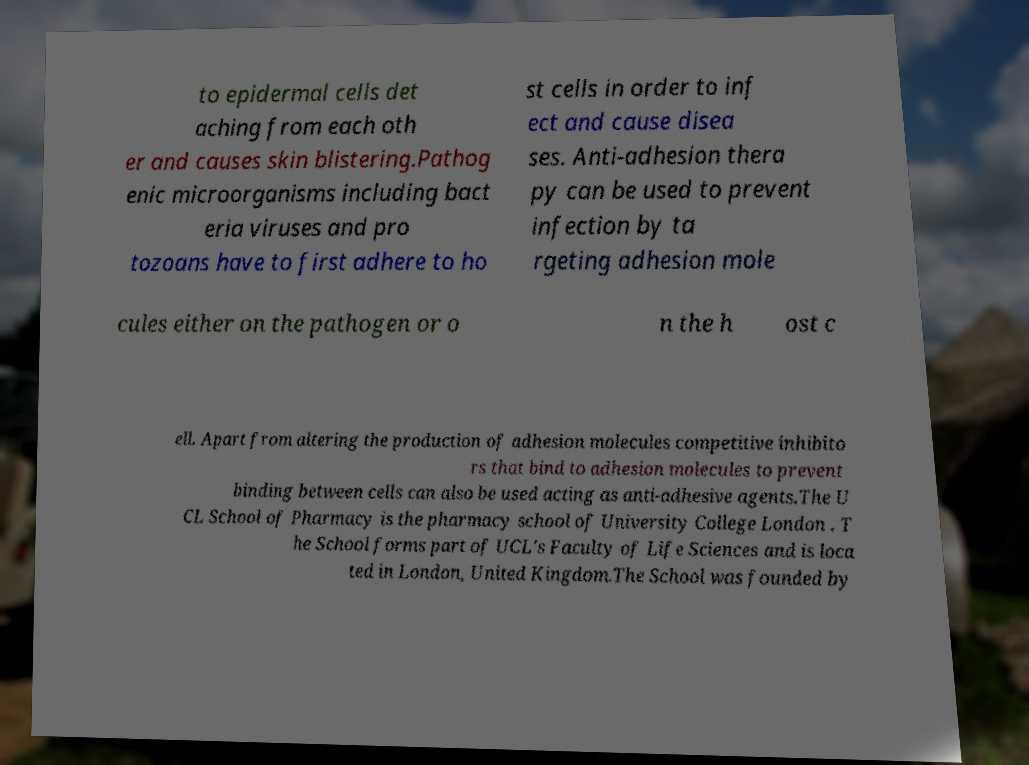Could you assist in decoding the text presented in this image and type it out clearly? to epidermal cells det aching from each oth er and causes skin blistering.Pathog enic microorganisms including bact eria viruses and pro tozoans have to first adhere to ho st cells in order to inf ect and cause disea ses. Anti-adhesion thera py can be used to prevent infection by ta rgeting adhesion mole cules either on the pathogen or o n the h ost c ell. Apart from altering the production of adhesion molecules competitive inhibito rs that bind to adhesion molecules to prevent binding between cells can also be used acting as anti-adhesive agents.The U CL School of Pharmacy is the pharmacy school of University College London . T he School forms part of UCL's Faculty of Life Sciences and is loca ted in London, United Kingdom.The School was founded by 